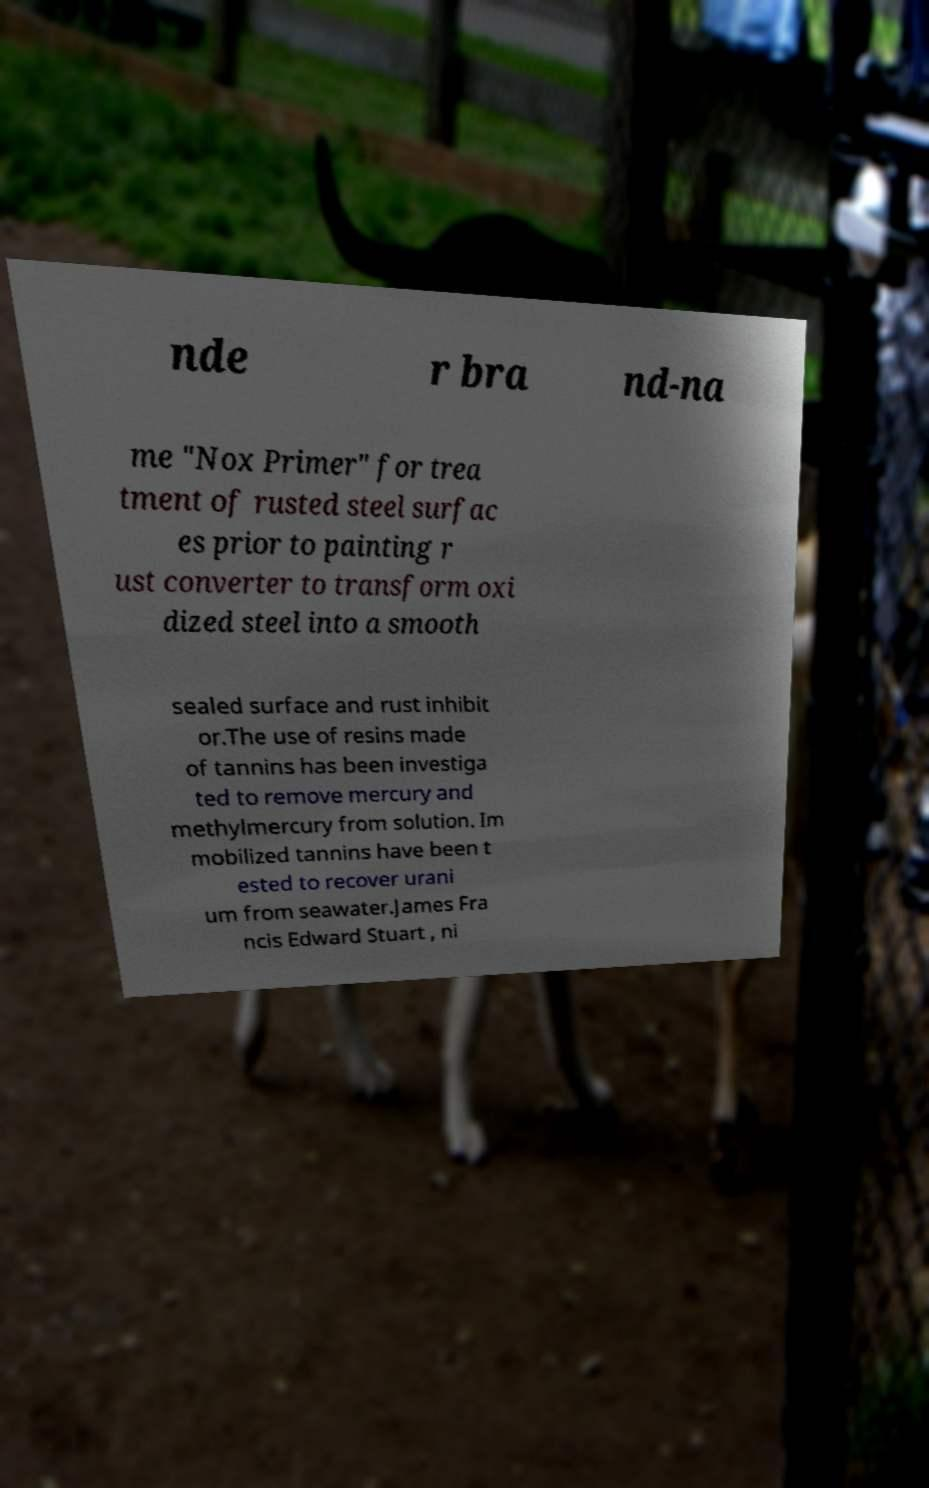I need the written content from this picture converted into text. Can you do that? nde r bra nd-na me "Nox Primer" for trea tment of rusted steel surfac es prior to painting r ust converter to transform oxi dized steel into a smooth sealed surface and rust inhibit or.The use of resins made of tannins has been investiga ted to remove mercury and methylmercury from solution. Im mobilized tannins have been t ested to recover urani um from seawater.James Fra ncis Edward Stuart , ni 